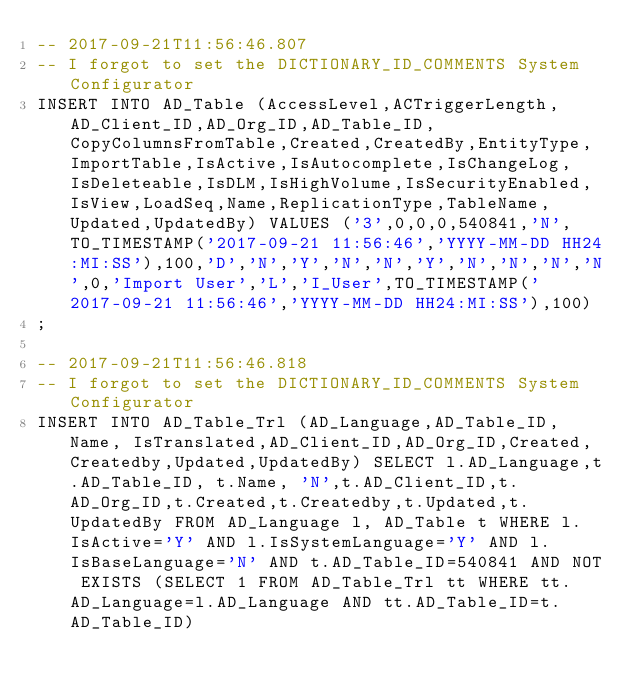Convert code to text. <code><loc_0><loc_0><loc_500><loc_500><_SQL_>-- 2017-09-21T11:56:46.807
-- I forgot to set the DICTIONARY_ID_COMMENTS System Configurator
INSERT INTO AD_Table (AccessLevel,ACTriggerLength,AD_Client_ID,AD_Org_ID,AD_Table_ID,CopyColumnsFromTable,Created,CreatedBy,EntityType,ImportTable,IsActive,IsAutocomplete,IsChangeLog,IsDeleteable,IsDLM,IsHighVolume,IsSecurityEnabled,IsView,LoadSeq,Name,ReplicationType,TableName,Updated,UpdatedBy) VALUES ('3',0,0,0,540841,'N',TO_TIMESTAMP('2017-09-21 11:56:46','YYYY-MM-DD HH24:MI:SS'),100,'D','N','Y','N','N','Y','N','N','N','N',0,'Import User','L','I_User',TO_TIMESTAMP('2017-09-21 11:56:46','YYYY-MM-DD HH24:MI:SS'),100)
;

-- 2017-09-21T11:56:46.818
-- I forgot to set the DICTIONARY_ID_COMMENTS System Configurator
INSERT INTO AD_Table_Trl (AD_Language,AD_Table_ID, Name, IsTranslated,AD_Client_ID,AD_Org_ID,Created,Createdby,Updated,UpdatedBy) SELECT l.AD_Language,t.AD_Table_ID, t.Name, 'N',t.AD_Client_ID,t.AD_Org_ID,t.Created,t.Createdby,t.Updated,t.UpdatedBy FROM AD_Language l, AD_Table t WHERE l.IsActive='Y' AND l.IsSystemLanguage='Y' AND l.IsBaseLanguage='N' AND t.AD_Table_ID=540841 AND NOT EXISTS (SELECT 1 FROM AD_Table_Trl tt WHERE tt.AD_Language=l.AD_Language AND tt.AD_Table_ID=t.AD_Table_ID)</code> 